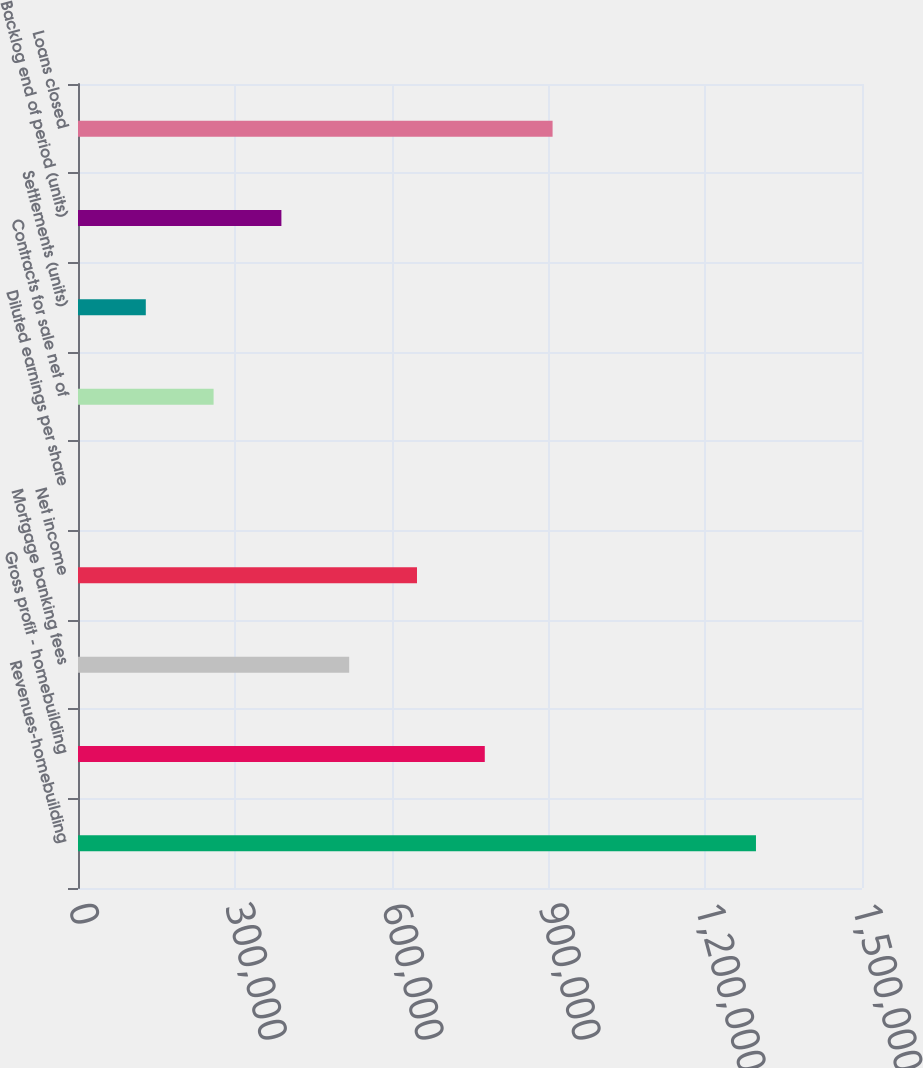Convert chart. <chart><loc_0><loc_0><loc_500><loc_500><bar_chart><fcel>Revenues-homebuilding<fcel>Gross profit - homebuilding<fcel>Mortgage banking fees<fcel>Net income<fcel>Diluted earnings per share<fcel>Contracts for sale net of<fcel>Settlements (units)<fcel>Backlog end of period (units)<fcel>Loans closed<nl><fcel>1.29714e+06<fcel>778290<fcel>518864<fcel>648577<fcel>14.14<fcel>259439<fcel>129727<fcel>389152<fcel>908002<nl></chart> 